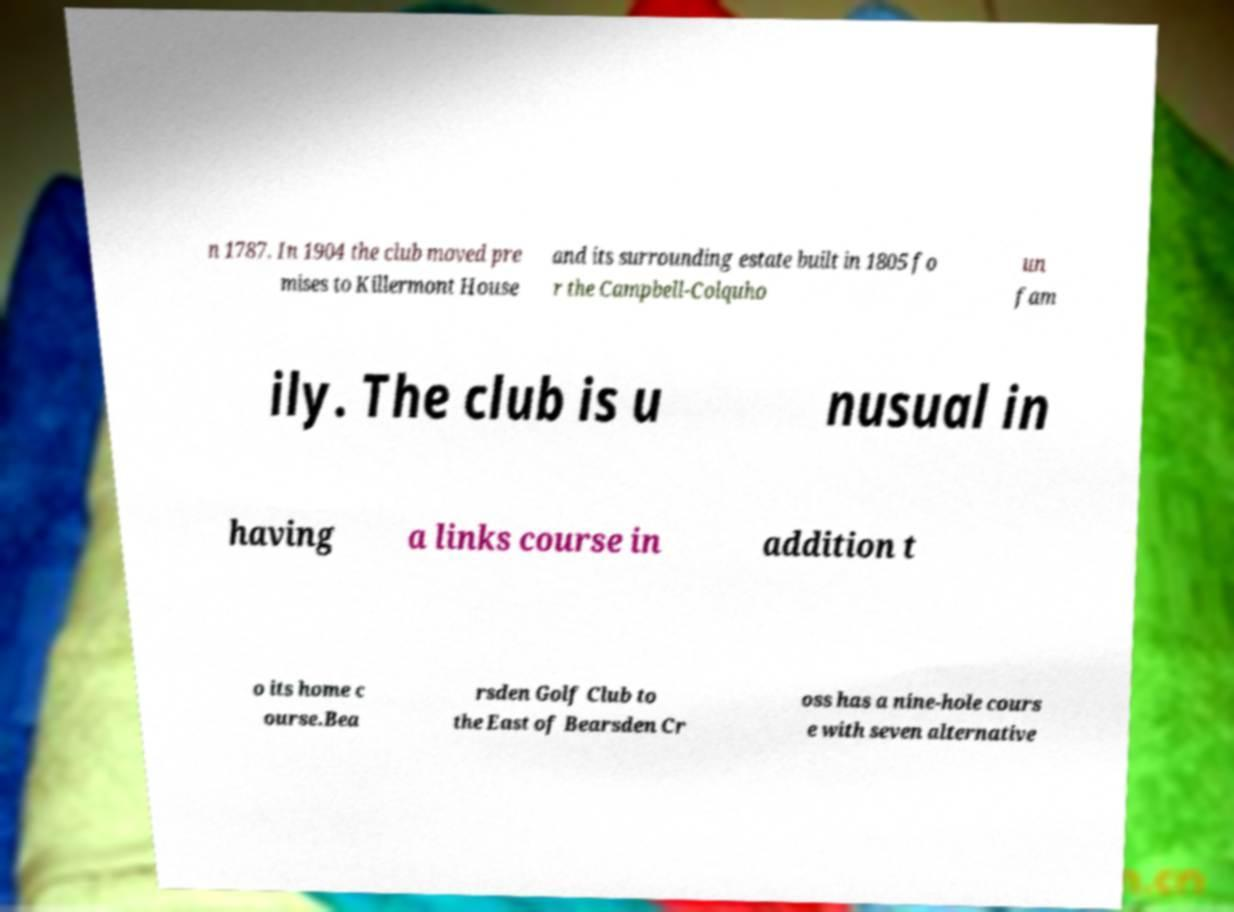Can you accurately transcribe the text from the provided image for me? n 1787. In 1904 the club moved pre mises to Killermont House and its surrounding estate built in 1805 fo r the Campbell-Colquho un fam ily. The club is u nusual in having a links course in addition t o its home c ourse.Bea rsden Golf Club to the East of Bearsden Cr oss has a nine-hole cours e with seven alternative 